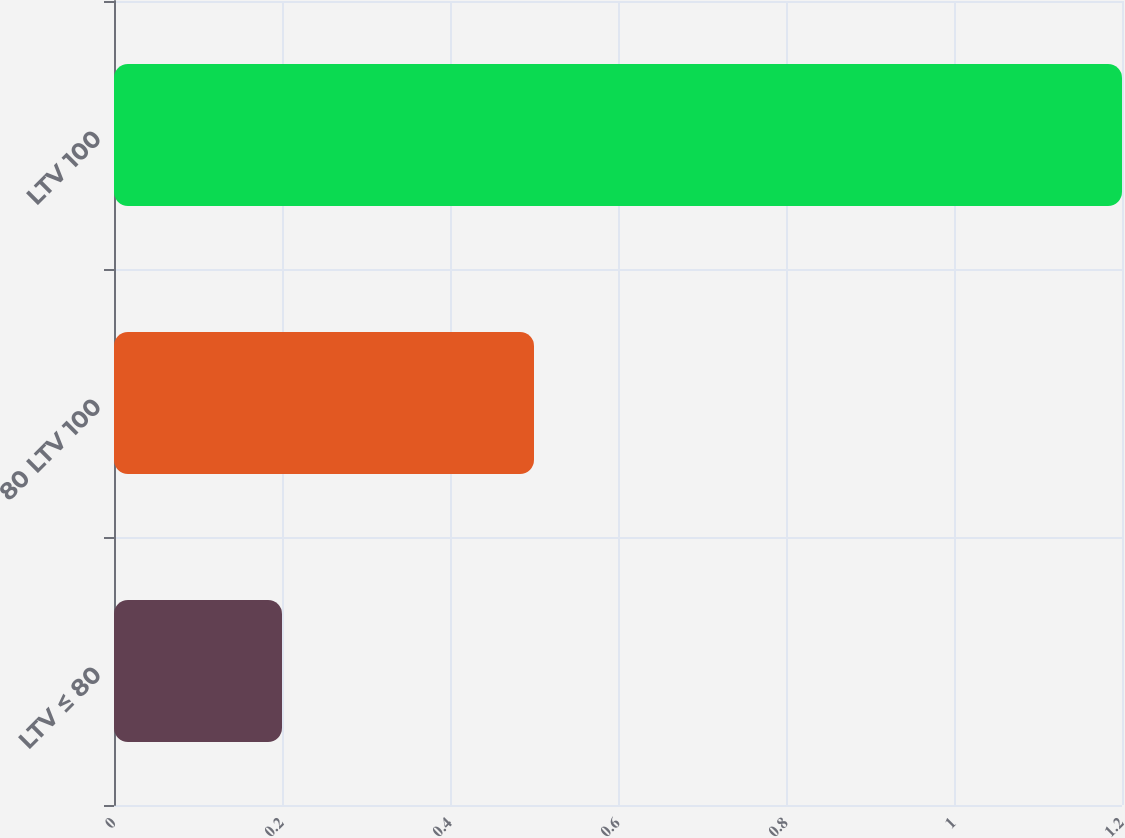Convert chart to OTSL. <chart><loc_0><loc_0><loc_500><loc_500><bar_chart><fcel>LTV ≤ 80<fcel>80 LTV 100<fcel>LTV 100<nl><fcel>0.2<fcel>0.5<fcel>1.2<nl></chart> 